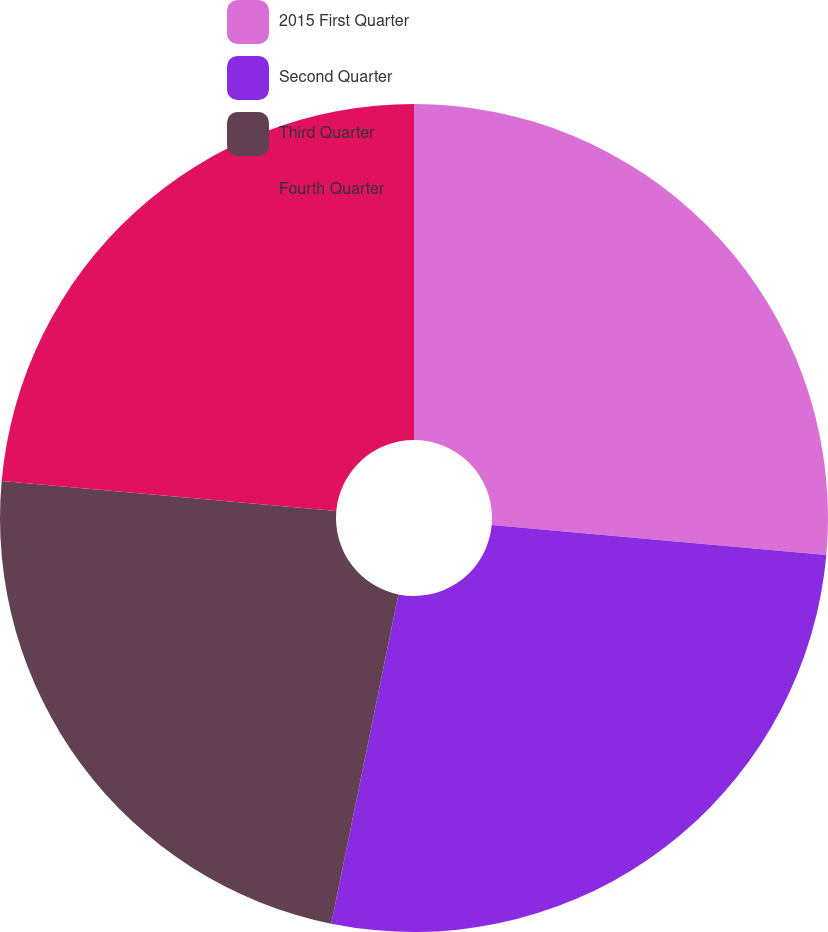Convert chart. <chart><loc_0><loc_0><loc_500><loc_500><pie_chart><fcel>2015 First Quarter<fcel>Second Quarter<fcel>Third Quarter<fcel>Fourth Quarter<nl><fcel>26.42%<fcel>26.78%<fcel>23.22%<fcel>23.57%<nl></chart> 